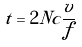<formula> <loc_0><loc_0><loc_500><loc_500>t = 2 N c \frac { v } { f }</formula> 